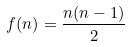Convert formula to latex. <formula><loc_0><loc_0><loc_500><loc_500>f ( n ) = \frac { n ( n - 1 ) } { 2 }</formula> 